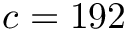<formula> <loc_0><loc_0><loc_500><loc_500>c = 1 9 2</formula> 